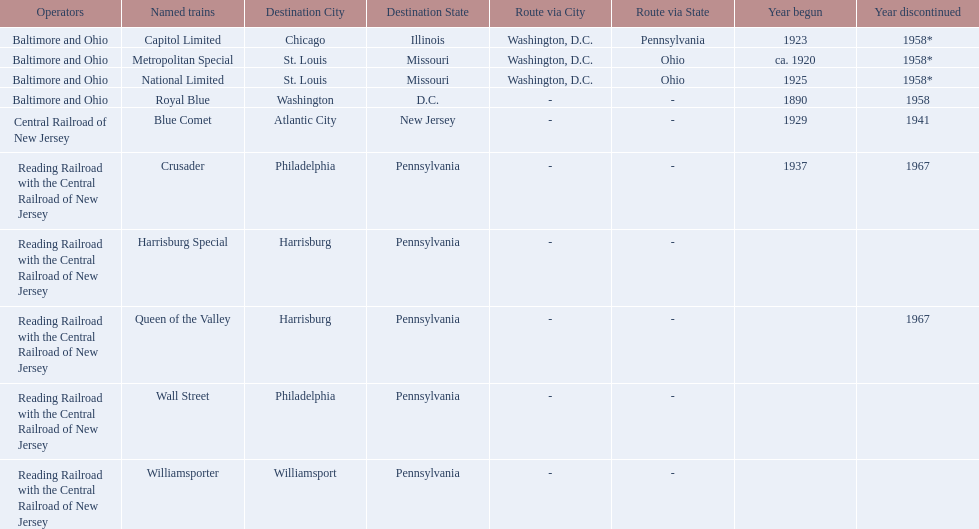What destinations are listed from the central railroad of new jersey terminal? Chicago, Illinois via Washington, D.C. and Pittsburgh, Pennsylvania, St. Louis, Missouri via Washington, D.C. and Cincinnati, Ohio, St. Louis, Missouri via Washington, D.C. and Cincinnati, Ohio, Washington, D.C., Atlantic City, New Jersey, Philadelphia, Pennsylvania, Harrisburg, Pennsylvania, Harrisburg, Pennsylvania, Philadelphia, Pennsylvania, Williamsport, Pennsylvania. Which of these destinations is listed first? Chicago, Illinois via Washington, D.C. and Pittsburgh, Pennsylvania. 